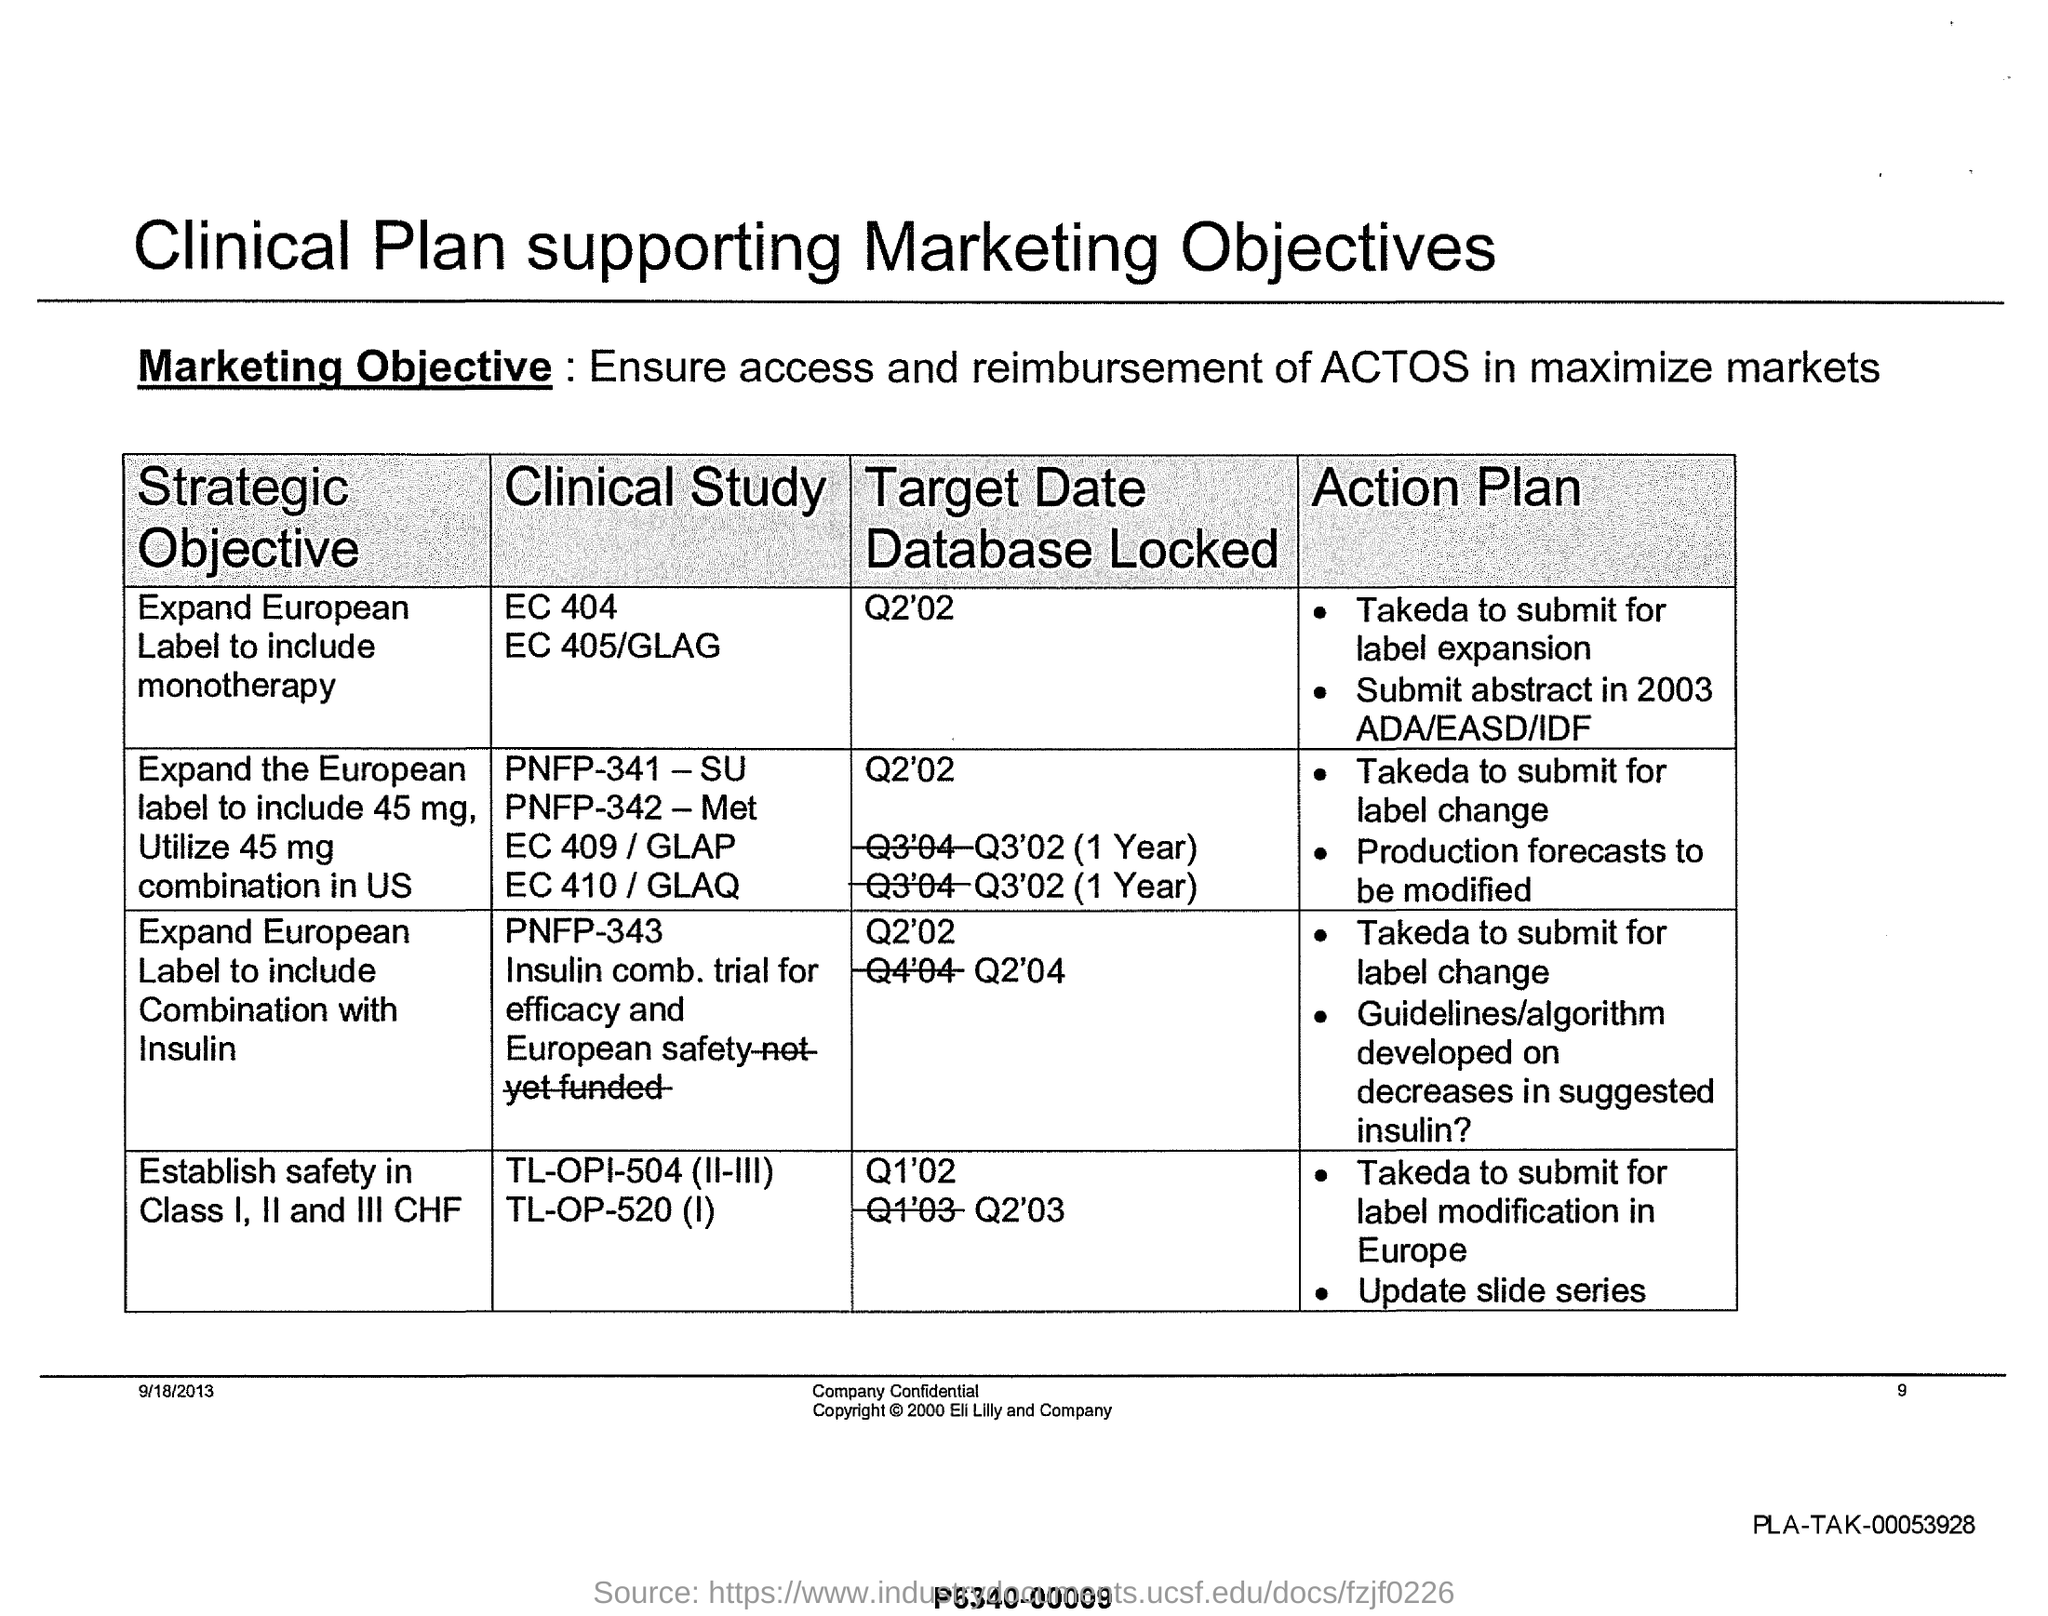Identify some key points in this picture. The marketing objective stated in the document is to guarantee access and payment for Actos in as many markets as possible. The page number mentioned in this document is 9. The date mentioned in this document is September 18, 2013. 